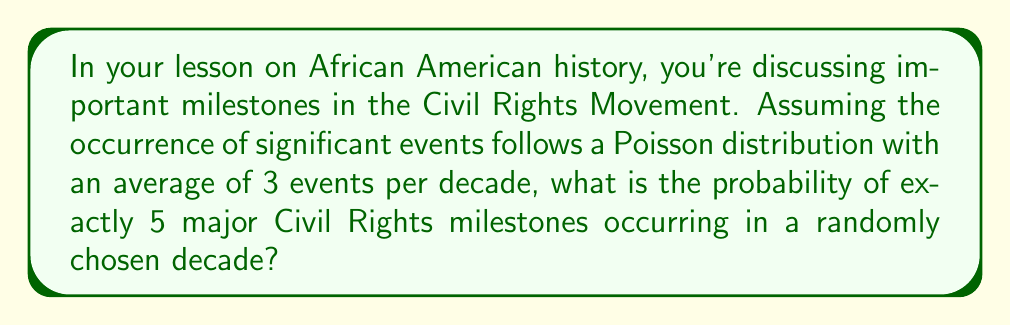What is the answer to this math problem? Let's approach this step-by-step:

1) The Poisson distribution is used to model the number of events occurring in a fixed interval of time or space, given the average rate of occurrence.

2) The probability mass function for a Poisson distribution is:

   $$P(X = k) = \frac{e^{-\lambda} \lambda^k}{k!}$$

   Where:
   - $\lambda$ is the average number of events per interval
   - $k$ is the number of events we're calculating the probability for
   - $e$ is Euler's number (approximately 2.71828)

3) In this case:
   - $\lambda = 3$ (average of 3 events per decade)
   - $k = 5$ (we're calculating the probability of exactly 5 events)

4) Let's substitute these values into the formula:

   $$P(X = 5) = \frac{e^{-3} 3^5}{5!}$$

5) Now, let's calculate step by step:
   - $e^{-3} \approx 0.0497871$
   - $3^5 = 243$
   - $5! = 5 \times 4 \times 3 \times 2 \times 1 = 120$

6) Putting it all together:

   $$P(X = 5) = \frac{0.0497871 \times 243}{120} \approx 0.10081$$

7) Converting to a percentage: 0.10081 × 100% ≈ 10.081%
Answer: 10.081% 